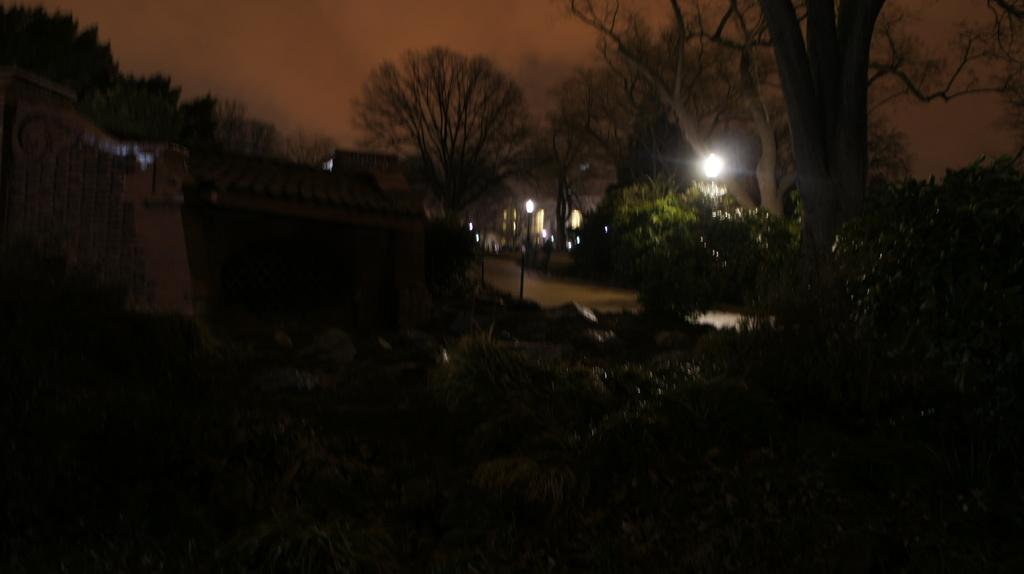What type of natural elements can be seen in the image? There are trees and plants in the image. What type of man-made structures are present in the image? There are street lamps and houses in the image. Can you describe the lighting conditions in the image? The image is slightly dark. Can you see anyone using a wrench in the image? There is no wrench present in the image. What type of pain is being experienced by the plants in the image? There is no indication of pain in the image, as plants do not experience pain. 